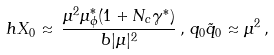<formula> <loc_0><loc_0><loc_500><loc_500>h X _ { 0 } \approx \, \frac { \mu ^ { 2 } \mu _ { \phi } ^ { * } ( 1 + N _ { c } \gamma ^ { * } ) } { b | \mu | ^ { 2 } } \, , \, q _ { 0 } \tilde { q } _ { 0 } \approx \mu ^ { 2 } \, ,</formula> 